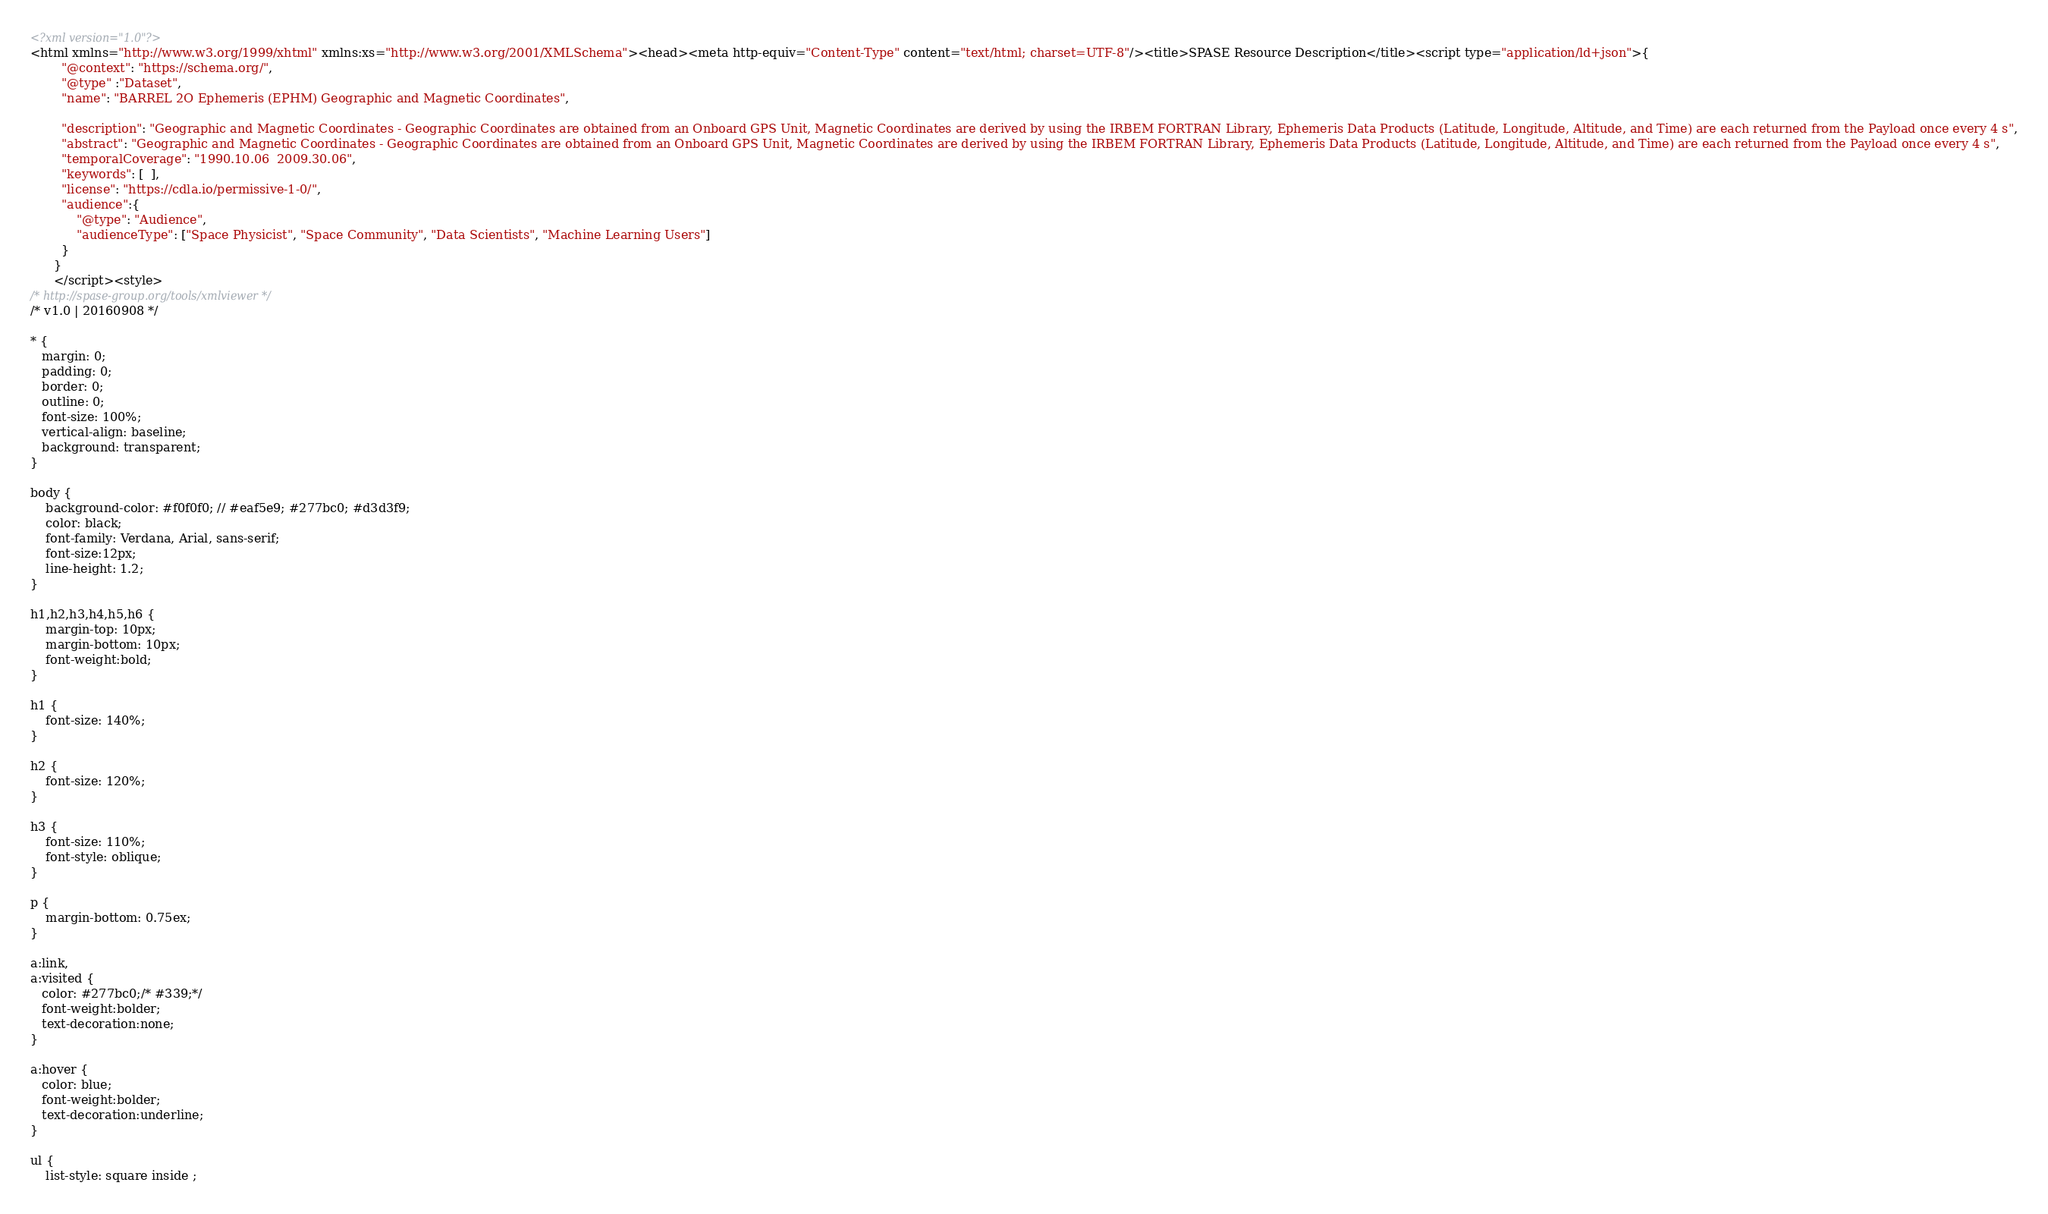Convert code to text. <code><loc_0><loc_0><loc_500><loc_500><_HTML_><?xml version="1.0"?>
<html xmlns="http://www.w3.org/1999/xhtml" xmlns:xs="http://www.w3.org/2001/XMLSchema"><head><meta http-equiv="Content-Type" content="text/html; charset=UTF-8"/><title>SPASE Resource Description</title><script type="application/ld+json">{
		"@context": "https://schema.org/",
		"@type" :"Dataset",
		"name": "BARREL 2O Ephemeris (EPHM) Geographic and Magnetic Coordinates",
     
 		"description": "Geographic and Magnetic Coordinates - Geographic Coordinates are obtained from an Onboard GPS Unit, Magnetic Coordinates are derived by using the IRBEM FORTRAN Library, Ephemeris Data Products (Latitude, Longitude, Altitude, and Time) are each returned from the Payload once every 4 s",
		"abstract": "Geographic and Magnetic Coordinates - Geographic Coordinates are obtained from an Onboard GPS Unit, Magnetic Coordinates are derived by using the IRBEM FORTRAN Library, Ephemeris Data Products (Latitude, Longitude, Altitude, and Time) are each returned from the Payload once every 4 s",
		"temporalCoverage": "1990.10.06  2009.30.06",
		"keywords": [  ],
		"license": "https://cdla.io/permissive-1-0/",
        "audience":{
            "@type": "Audience",
            "audienceType": ["Space Physicist", "Space Community", "Data Scientists", "Machine Learning Users"]
        }
	  }
	  </script><style>
/* http://spase-group.org/tools/xmlviewer */
/* v1.0 | 20160908 */

* {
   margin: 0;
   padding: 0;
   border: 0;
   outline: 0;
   font-size: 100%;
   vertical-align: baseline;
   background: transparent;
}

body {
	background-color: #f0f0f0; // #eaf5e9; #277bc0; #d3d3f9;
	color: black;
	font-family: Verdana, Arial, sans-serif; 
	font-size:12px; 
	line-height: 1.2;
}
 
h1,h2,h3,h4,h5,h6 {
	margin-top: 10px;
	margin-bottom: 10px;
	font-weight:bold;
}

h1 {
	font-size: 140%;
}

h2 {
	font-size: 120%;
}

h3 {
	font-size: 110%;
	font-style: oblique;
}

p {
	margin-bottom: 0.75ex;
}

a:link,
a:visited {
   color: #277bc0;/* #339;*/
   font-weight:bolder; 
   text-decoration:none; 
}

a:hover {
   color: blue;
   font-weight:bolder; 
   text-decoration:underline; 
}

ul {
	list-style: square inside ;</code> 